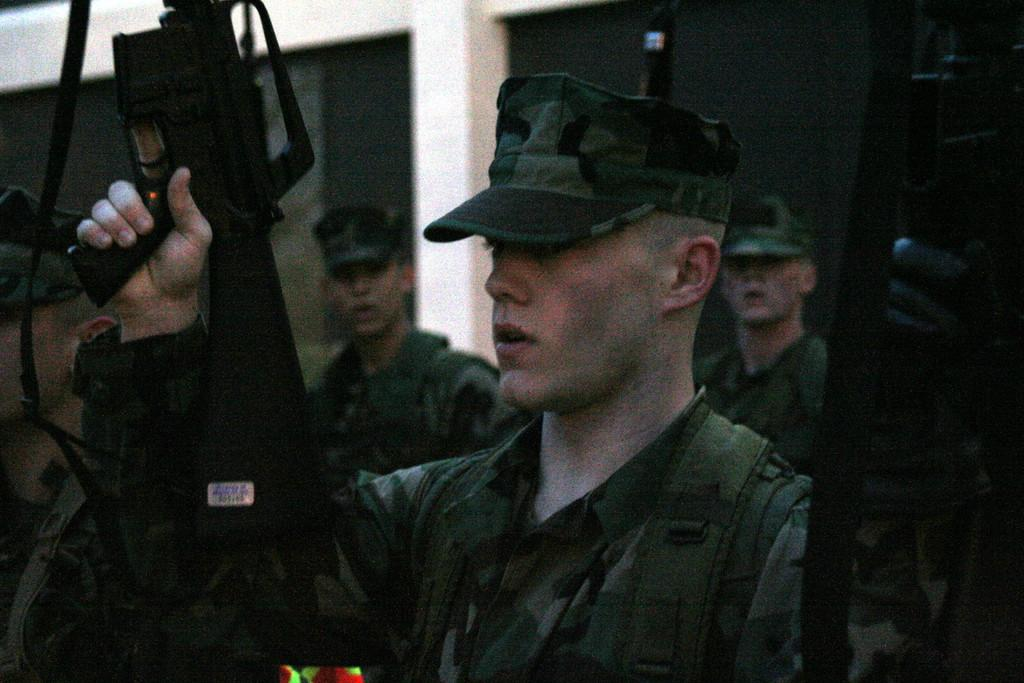How many people are in the image? There are people in the image, but the exact number is not specified. What are the people doing in the image? The people are standing and holding rifles. What are the people wearing in the image? The people are wearing uniforms. What can be seen in the background of the image? There is a wall in the background of the image. What type of eggs can be seen in the image? There are no eggs present in the image. What is the purpose of the protest in the image? There is no protest depicted in the image. 